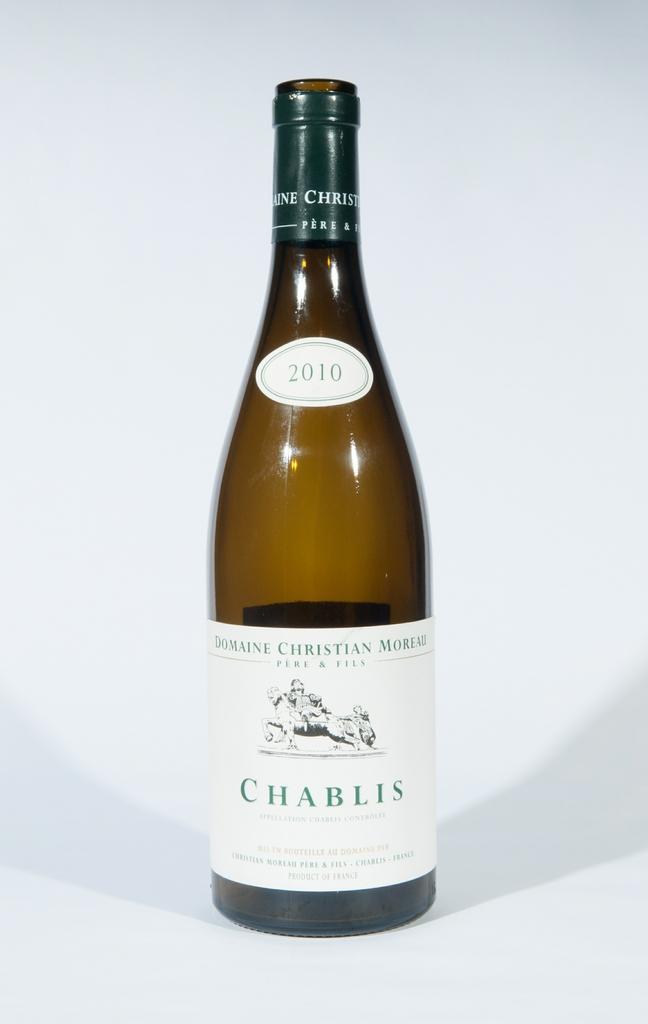Could you give a brief overview of what you see in this image? This image consists of a liquor bottle and a white color background. This image is taken may be in a room. 